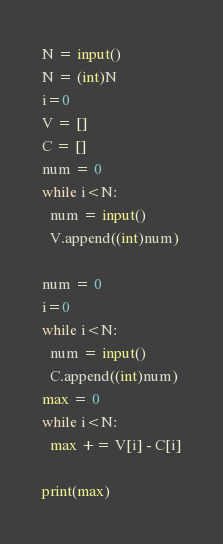<code> <loc_0><loc_0><loc_500><loc_500><_Python_>N = input()
N = (int)N
i=0
V = []
C = []
num = 0
while i<N:
  num = input()
  V.append((int)num)
 
num = 0
i=0
while i<N:
  num = input()
  C.append((int)num)
max = 0
while i<N:
  max += V[i] - C[i]
  
print(max)</code> 